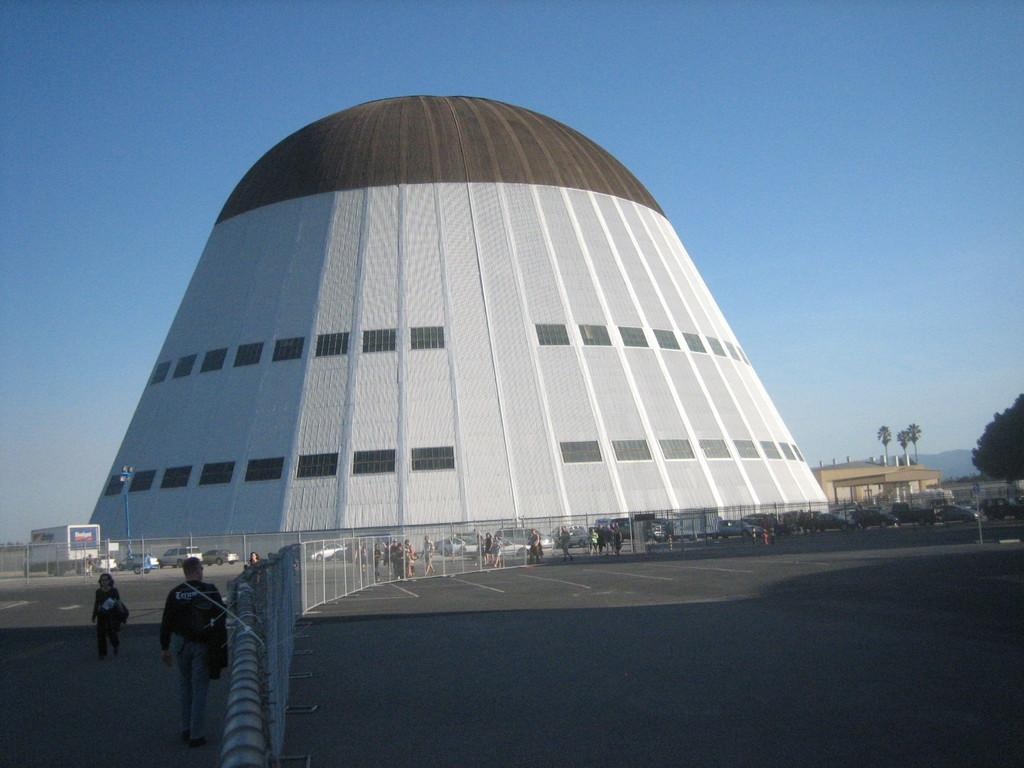What is the main structure in the center of the image? There is a building in the center of the image. What can be seen in the foreground of the image? There is fencing, vehicles, and persons in the foreground. What type of pathway is visible in the foreground? A road is visible in the foreground. What is visible in the background of the image? The sky is visible in the background. What type of toy can be seen in the hands of the persons in the image? There is no toy visible in the hands of the persons in the image. What message of peace is conveyed by the building in the image? The image does not convey any specific message of peace; it simply shows a building, fencing, vehicles, persons, a road, and the sky. 